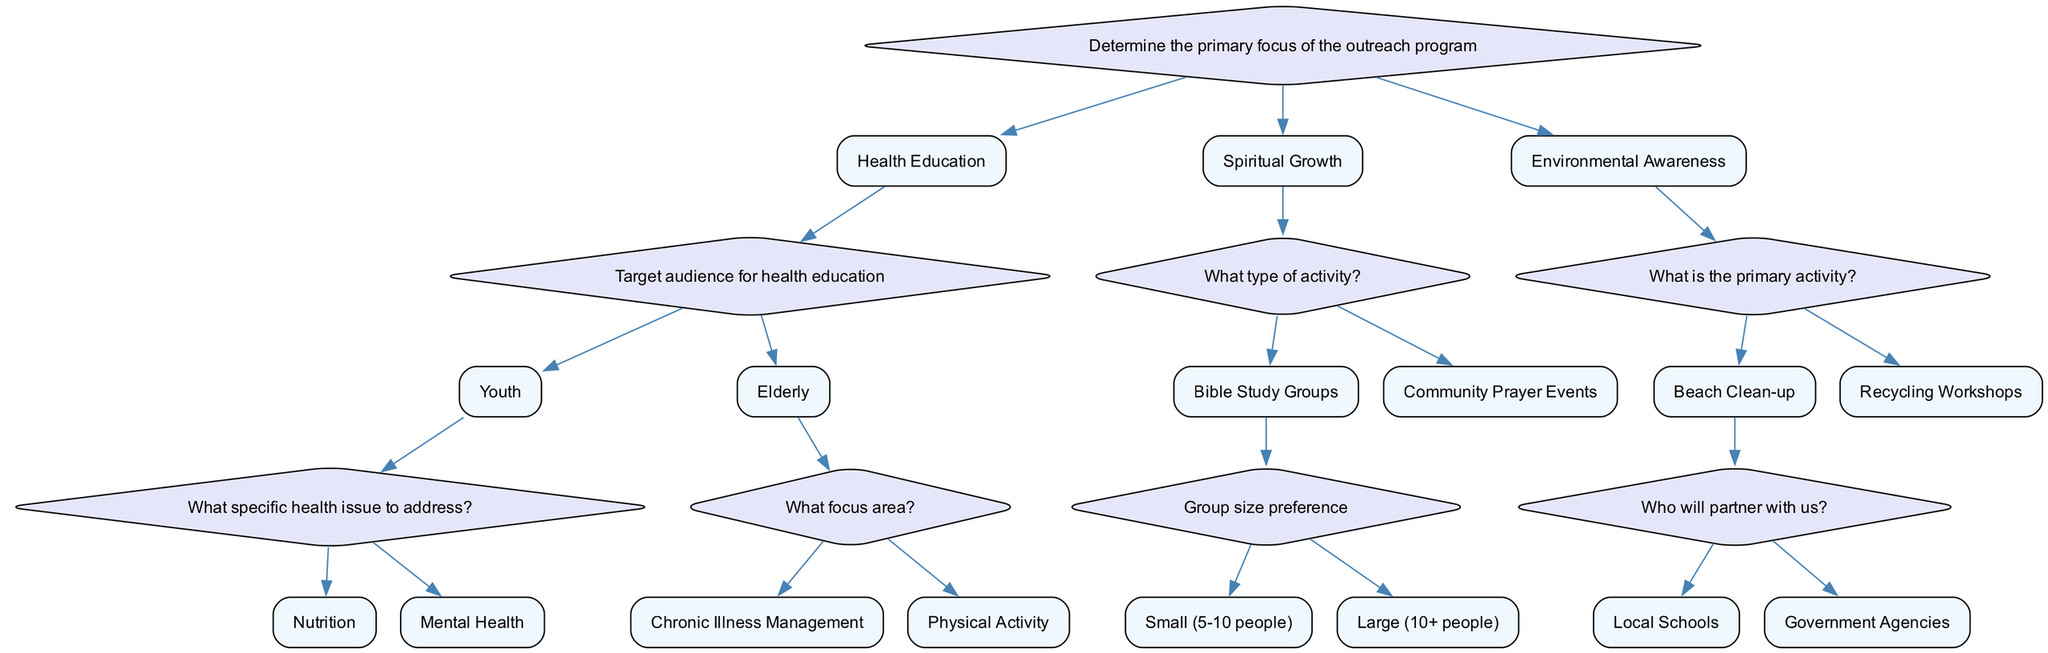What is the primary focus of the outreach program? The root node of the decision tree explicitly states that the primary focus of the outreach program must be determined first. This is the first question, and it has three main options: Health Education, Spiritual Growth, and Environmental Awareness.
Answer: Health Education Which target audience is associated with health education? Following the decision path from the primary focus (Health Education), the next question asks to identify the target audience. The options available are Youth and Elderly, which are directly linked to health education as per the decision tree structure.
Answer: Youth What specific health issue can be addressed for the youth audience? Continuing from the Youth option under Health Education, the next question addresses specific health issues that can be targeted. There are two options presented: Nutrition and Mental Health, which determine the focus for youth within the health education bracket.
Answer: Nutrition What is one type of community activity listed under spiritual growth? In the subtree for Spiritual Growth, there are two types of activities identified: Bible Study Groups and Community Prayer Events. This question seeks information from this part of the decision tree directly.
Answer: Bible Study Groups What is the primary activity for environmental awareness? The segment of the decision tree concerning Environmental Awareness indicates two main options: Beach Clean-up and Recycling Workshops. This question addresses this category directly, highlighting the focus of these community outreach activities.
Answer: Beach Clean-up How many partner options are available for a beach clean-up? Under the Beach Clean-up option, the decision tree specifies two potential partners: Local Schools and Government Agencies. This requires counting the available partnership options specified in the tree.
Answer: 2 What is the group size preference for bible study groups? Under the Bible Study Groups segment, there are two specific preferences for group size indicated: Small (5-10 people) and Large (10+ people). The question directly refers to this branch of the decision tree.
Answer: Small (5-10 people) If the primary focus is on spiritual growth and the activity chosen is a community prayer event, what follow-up question is applicable? When Spiritual Growth is the primary focus and Community Prayer Events have been selected, there are no further options given as it is a terminal node. This question confirms that no additional inquiry follows under this option.
Answer: None 